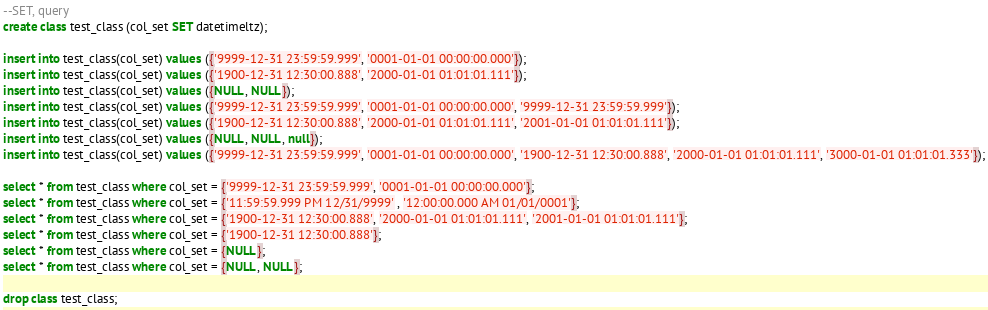<code> <loc_0><loc_0><loc_500><loc_500><_SQL_>--SET, query
create class test_class (col_set SET datetimeltz);

insert into test_class(col_set) values ({'9999-12-31 23:59:59.999', '0001-01-01 00:00:00.000'});
insert into test_class(col_set) values ({'1900-12-31 12:30:00.888', '2000-01-01 01:01:01.111'});
insert into test_class(col_set) values ({NULL, NULL});
insert into test_class(col_set) values ({'9999-12-31 23:59:59.999', '0001-01-01 00:00:00.000', '9999-12-31 23:59:59.999'});
insert into test_class(col_set) values ({'1900-12-31 12:30:00.888', '2000-01-01 01:01:01.111', '2001-01-01 01:01:01.111'});
insert into test_class(col_set) values ({NULL, NULL, null});
insert into test_class(col_set) values ({'9999-12-31 23:59:59.999', '0001-01-01 00:00:00.000', '1900-12-31 12:30:00.888', '2000-01-01 01:01:01.111', '3000-01-01 01:01:01.333'});

select * from test_class where col_set = {'9999-12-31 23:59:59.999', '0001-01-01 00:00:00.000'};
select * from test_class where col_set = {'11:59:59.999 PM 12/31/9999' , '12:00:00.000 AM 01/01/0001'};
select * from test_class where col_set = {'1900-12-31 12:30:00.888', '2000-01-01 01:01:01.111', '2001-01-01 01:01:01.111'};
select * from test_class where col_set = {'1900-12-31 12:30:00.888'};
select * from test_class where col_set = {NULL};
select * from test_class where col_set = {NULL, NULL};

drop class test_class;
</code> 